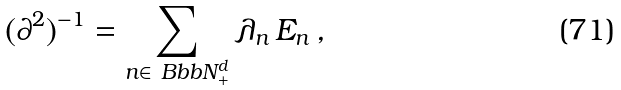<formula> <loc_0><loc_0><loc_500><loc_500>( \partial ^ { 2 } ) ^ { - 1 } = \sum _ { n \in { \ B b b N } _ { + } ^ { d } } \lambda _ { n } \, E _ { n } \, ,</formula> 